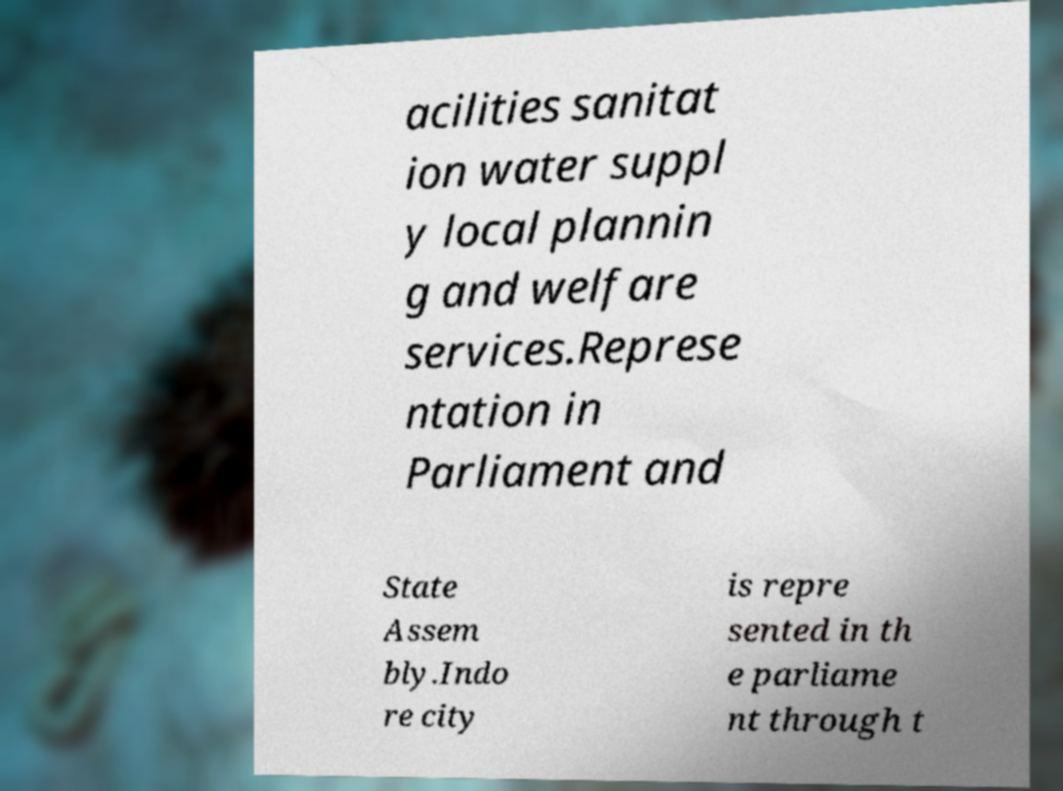Could you extract and type out the text from this image? acilities sanitat ion water suppl y local plannin g and welfare services.Represe ntation in Parliament and State Assem bly.Indo re city is repre sented in th e parliame nt through t 